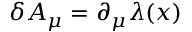<formula> <loc_0><loc_0><loc_500><loc_500>\delta A _ { \mu } = \partial _ { \mu } \lambda ( x )</formula> 